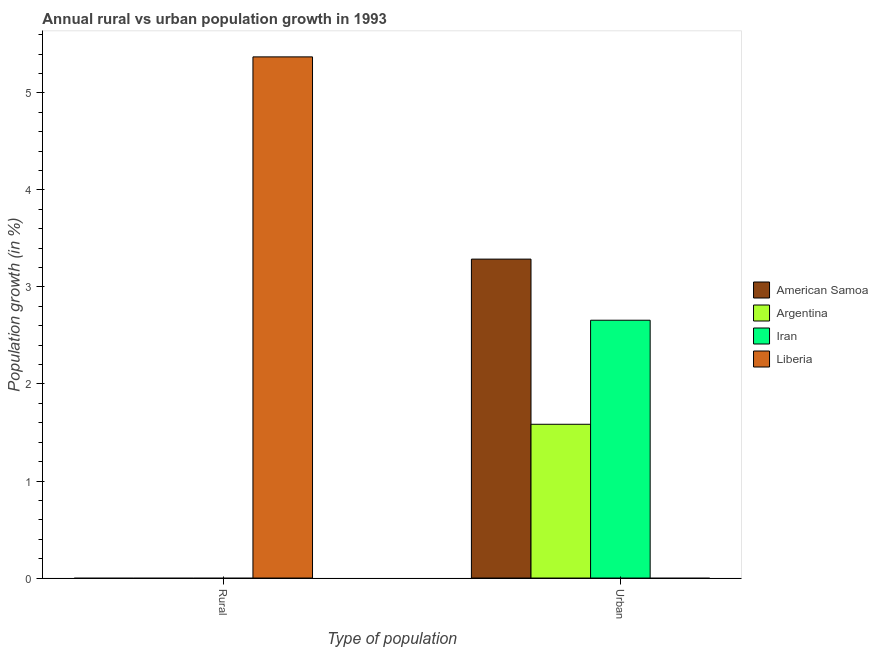How many bars are there on the 1st tick from the right?
Your answer should be compact. 3. What is the label of the 2nd group of bars from the left?
Ensure brevity in your answer.  Urban . Across all countries, what is the maximum rural population growth?
Provide a short and direct response. 5.37. Across all countries, what is the minimum urban population growth?
Make the answer very short. 0. In which country was the rural population growth maximum?
Your answer should be very brief. Liberia. What is the total urban population growth in the graph?
Keep it short and to the point. 7.53. What is the difference between the urban population growth in Iran and that in American Samoa?
Your response must be concise. -0.63. What is the difference between the rural population growth in American Samoa and the urban population growth in Iran?
Offer a very short reply. -2.66. What is the average rural population growth per country?
Offer a terse response. 1.34. In how many countries, is the rural population growth greater than 5.4 %?
Offer a very short reply. 0. What is the ratio of the urban population growth in American Samoa to that in Argentina?
Your answer should be compact. 2.07. Is the urban population growth in Iran less than that in American Samoa?
Offer a very short reply. Yes. In how many countries, is the urban population growth greater than the average urban population growth taken over all countries?
Your answer should be compact. 2. How many bars are there?
Your response must be concise. 4. Are all the bars in the graph horizontal?
Your answer should be very brief. No. How many countries are there in the graph?
Make the answer very short. 4. What is the difference between two consecutive major ticks on the Y-axis?
Give a very brief answer. 1. Are the values on the major ticks of Y-axis written in scientific E-notation?
Ensure brevity in your answer.  No. Does the graph contain grids?
Offer a terse response. No. What is the title of the graph?
Give a very brief answer. Annual rural vs urban population growth in 1993. What is the label or title of the X-axis?
Your answer should be very brief. Type of population. What is the label or title of the Y-axis?
Your answer should be very brief. Population growth (in %). What is the Population growth (in %) in Argentina in Rural?
Keep it short and to the point. 0. What is the Population growth (in %) in Iran in Rural?
Your answer should be very brief. 0. What is the Population growth (in %) of Liberia in Rural?
Make the answer very short. 5.37. What is the Population growth (in %) of American Samoa in Urban ?
Keep it short and to the point. 3.29. What is the Population growth (in %) in Argentina in Urban ?
Make the answer very short. 1.58. What is the Population growth (in %) of Iran in Urban ?
Offer a terse response. 2.66. What is the Population growth (in %) in Liberia in Urban ?
Give a very brief answer. 0. Across all Type of population, what is the maximum Population growth (in %) in American Samoa?
Keep it short and to the point. 3.29. Across all Type of population, what is the maximum Population growth (in %) in Argentina?
Keep it short and to the point. 1.58. Across all Type of population, what is the maximum Population growth (in %) in Iran?
Make the answer very short. 2.66. Across all Type of population, what is the maximum Population growth (in %) of Liberia?
Offer a terse response. 5.37. Across all Type of population, what is the minimum Population growth (in %) of American Samoa?
Offer a terse response. 0. What is the total Population growth (in %) of American Samoa in the graph?
Ensure brevity in your answer.  3.29. What is the total Population growth (in %) in Argentina in the graph?
Give a very brief answer. 1.58. What is the total Population growth (in %) of Iran in the graph?
Offer a terse response. 2.66. What is the total Population growth (in %) of Liberia in the graph?
Provide a succinct answer. 5.37. What is the average Population growth (in %) of American Samoa per Type of population?
Keep it short and to the point. 1.64. What is the average Population growth (in %) in Argentina per Type of population?
Provide a succinct answer. 0.79. What is the average Population growth (in %) of Iran per Type of population?
Make the answer very short. 1.33. What is the average Population growth (in %) of Liberia per Type of population?
Offer a terse response. 2.69. What is the difference between the Population growth (in %) in American Samoa and Population growth (in %) in Argentina in Urban ?
Keep it short and to the point. 1.7. What is the difference between the Population growth (in %) in American Samoa and Population growth (in %) in Iran in Urban ?
Offer a very short reply. 0.63. What is the difference between the Population growth (in %) of Argentina and Population growth (in %) of Iran in Urban ?
Keep it short and to the point. -1.07. What is the difference between the highest and the lowest Population growth (in %) in American Samoa?
Offer a very short reply. 3.29. What is the difference between the highest and the lowest Population growth (in %) in Argentina?
Offer a very short reply. 1.58. What is the difference between the highest and the lowest Population growth (in %) of Iran?
Provide a short and direct response. 2.66. What is the difference between the highest and the lowest Population growth (in %) of Liberia?
Keep it short and to the point. 5.37. 